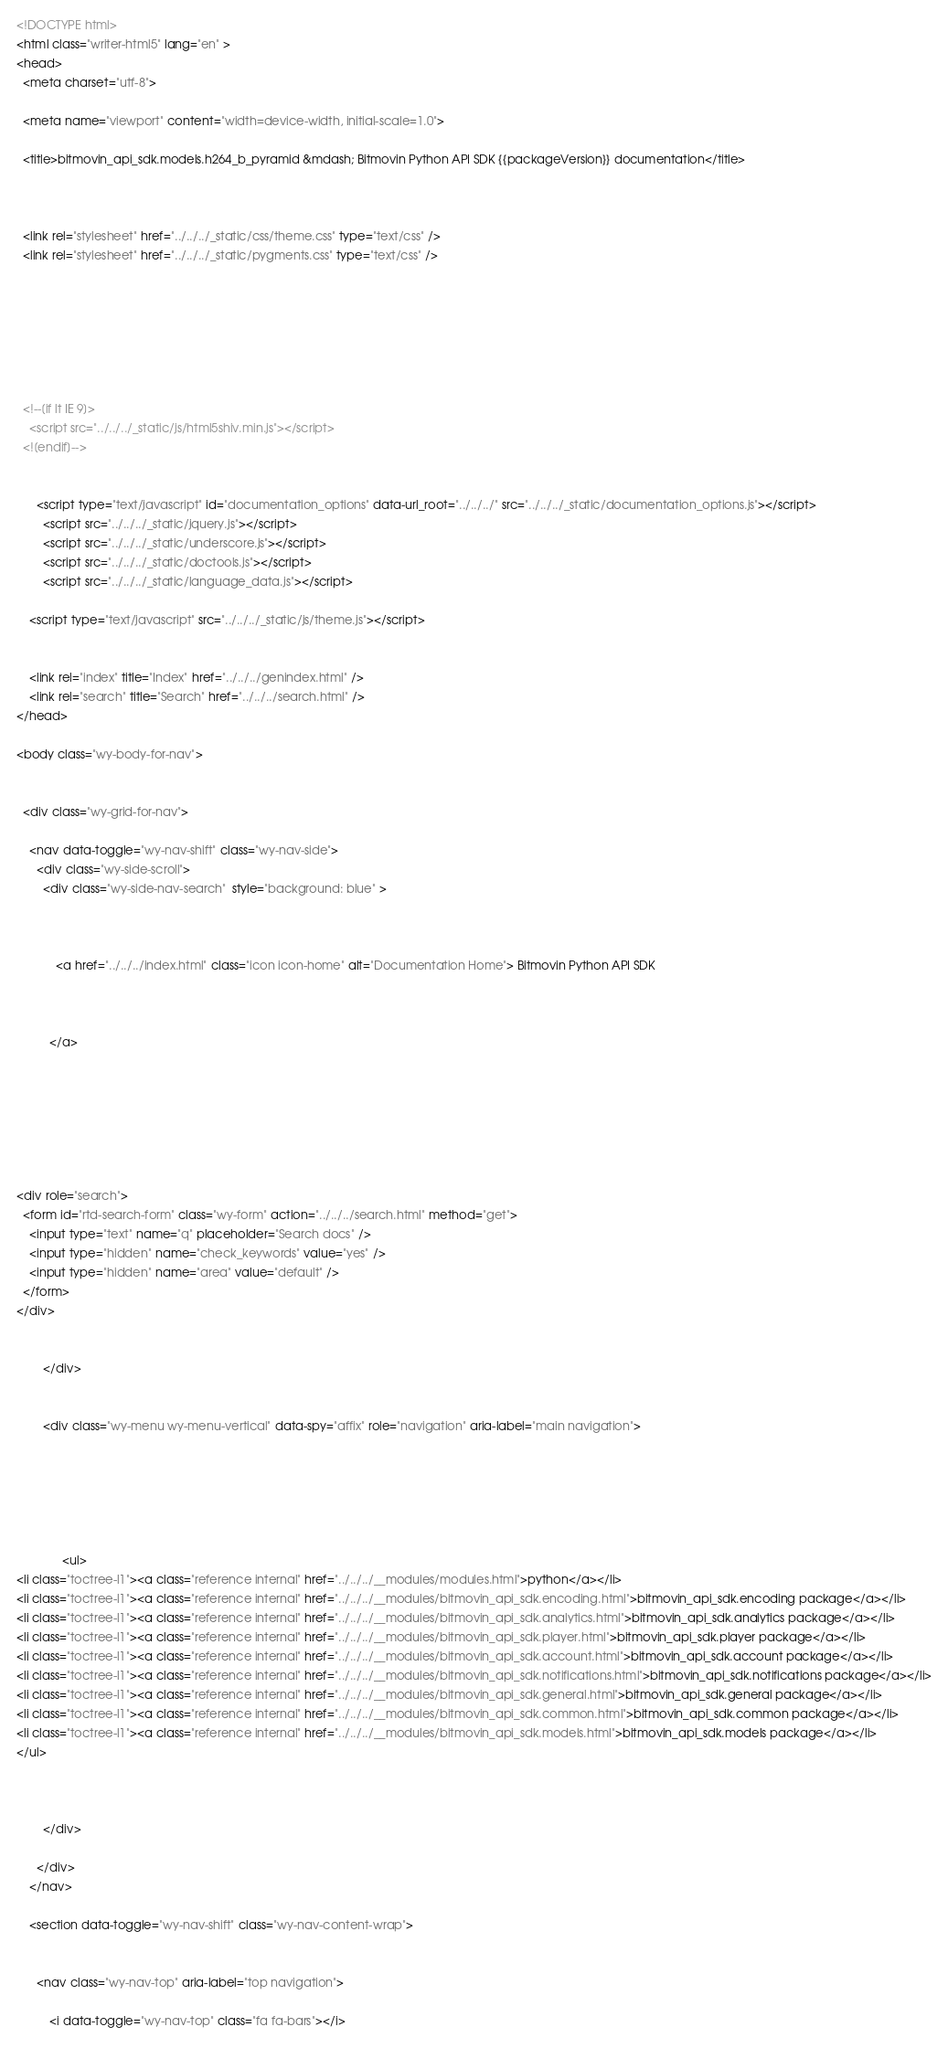<code> <loc_0><loc_0><loc_500><loc_500><_HTML_>

<!DOCTYPE html>
<html class="writer-html5" lang="en" >
<head>
  <meta charset="utf-8">
  
  <meta name="viewport" content="width=device-width, initial-scale=1.0">
  
  <title>bitmovin_api_sdk.models.h264_b_pyramid &mdash; Bitmovin Python API SDK {{packageVersion}} documentation</title>
  

  
  <link rel="stylesheet" href="../../../_static/css/theme.css" type="text/css" />
  <link rel="stylesheet" href="../../../_static/pygments.css" type="text/css" />

  
  
  
  

  
  <!--[if lt IE 9]>
    <script src="../../../_static/js/html5shiv.min.js"></script>
  <![endif]-->
  
    
      <script type="text/javascript" id="documentation_options" data-url_root="../../../" src="../../../_static/documentation_options.js"></script>
        <script src="../../../_static/jquery.js"></script>
        <script src="../../../_static/underscore.js"></script>
        <script src="../../../_static/doctools.js"></script>
        <script src="../../../_static/language_data.js"></script>
    
    <script type="text/javascript" src="../../../_static/js/theme.js"></script>

    
    <link rel="index" title="Index" href="../../../genindex.html" />
    <link rel="search" title="Search" href="../../../search.html" /> 
</head>

<body class="wy-body-for-nav">

   
  <div class="wy-grid-for-nav">
    
    <nav data-toggle="wy-nav-shift" class="wy-nav-side">
      <div class="wy-side-scroll">
        <div class="wy-side-nav-search"  style="background: blue" >
          

          
            <a href="../../../index.html" class="icon icon-home" alt="Documentation Home"> Bitmovin Python API SDK
          

          
          </a>

          
            
            
          

          
<div role="search">
  <form id="rtd-search-form" class="wy-form" action="../../../search.html" method="get">
    <input type="text" name="q" placeholder="Search docs" />
    <input type="hidden" name="check_keywords" value="yes" />
    <input type="hidden" name="area" value="default" />
  </form>
</div>

          
        </div>

        
        <div class="wy-menu wy-menu-vertical" data-spy="affix" role="navigation" aria-label="main navigation">
          
            
            
              
            
            
              <ul>
<li class="toctree-l1"><a class="reference internal" href="../../../__modules/modules.html">python</a></li>
<li class="toctree-l1"><a class="reference internal" href="../../../__modules/bitmovin_api_sdk.encoding.html">bitmovin_api_sdk.encoding package</a></li>
<li class="toctree-l1"><a class="reference internal" href="../../../__modules/bitmovin_api_sdk.analytics.html">bitmovin_api_sdk.analytics package</a></li>
<li class="toctree-l1"><a class="reference internal" href="../../../__modules/bitmovin_api_sdk.player.html">bitmovin_api_sdk.player package</a></li>
<li class="toctree-l1"><a class="reference internal" href="../../../__modules/bitmovin_api_sdk.account.html">bitmovin_api_sdk.account package</a></li>
<li class="toctree-l1"><a class="reference internal" href="../../../__modules/bitmovin_api_sdk.notifications.html">bitmovin_api_sdk.notifications package</a></li>
<li class="toctree-l1"><a class="reference internal" href="../../../__modules/bitmovin_api_sdk.general.html">bitmovin_api_sdk.general package</a></li>
<li class="toctree-l1"><a class="reference internal" href="../../../__modules/bitmovin_api_sdk.common.html">bitmovin_api_sdk.common package</a></li>
<li class="toctree-l1"><a class="reference internal" href="../../../__modules/bitmovin_api_sdk.models.html">bitmovin_api_sdk.models package</a></li>
</ul>

            
          
        </div>
        
      </div>
    </nav>

    <section data-toggle="wy-nav-shift" class="wy-nav-content-wrap">

      
      <nav class="wy-nav-top" aria-label="top navigation">
        
          <i data-toggle="wy-nav-top" class="fa fa-bars"></i></code> 